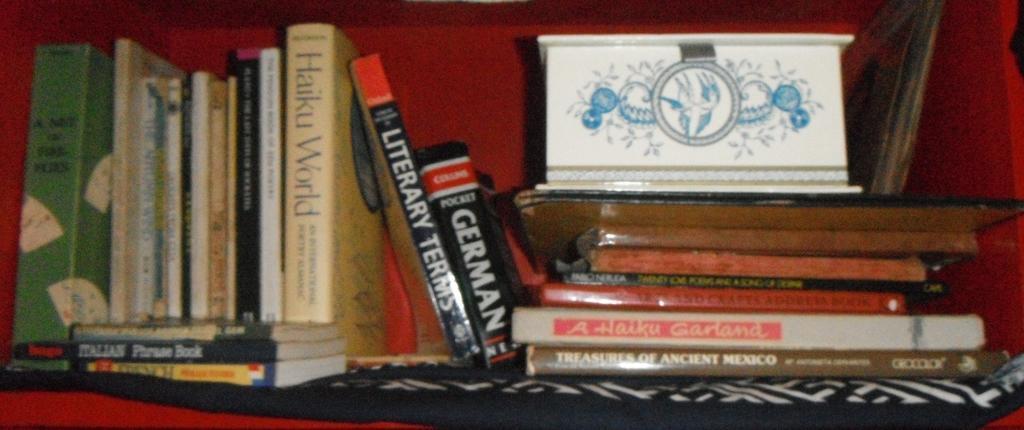Describe this image in one or two sentences. This is a zoomed in picture. In the center there is a cabinet containing a white color box and many number of books and we can see the text is written on the cover of the books. 